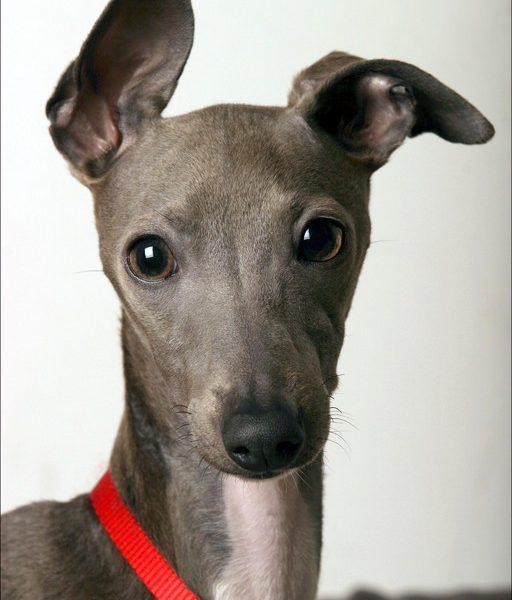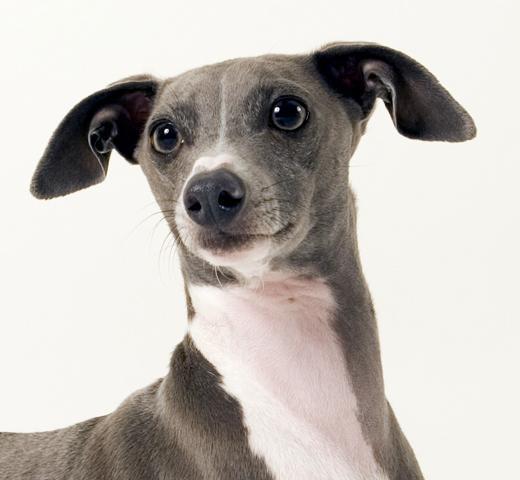The first image is the image on the left, the second image is the image on the right. For the images displayed, is the sentence "One of the dogs has a collar." factually correct? Answer yes or no. Yes. 